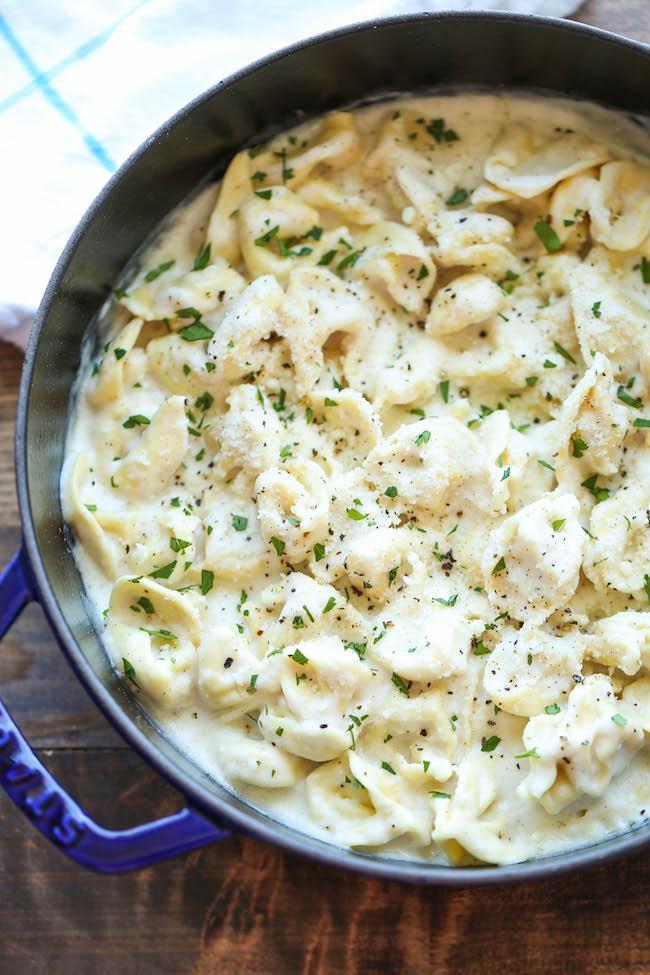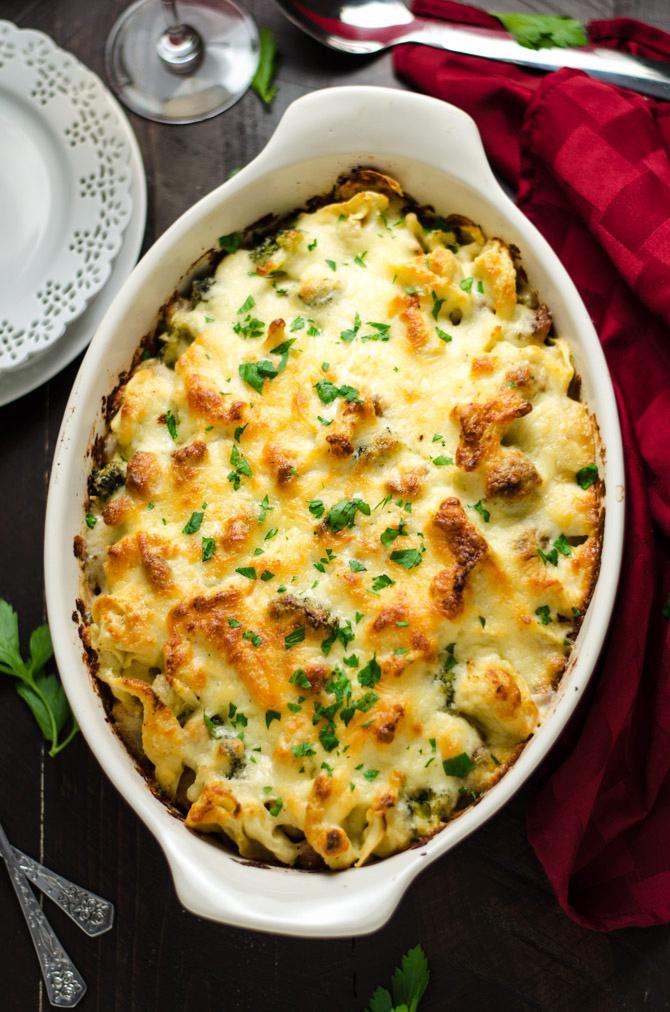The first image is the image on the left, the second image is the image on the right. For the images shown, is this caption "The right image contains a fork." true? Answer yes or no. No. The first image is the image on the left, the second image is the image on the right. For the images shown, is this caption "All broccoli dishes are served on white plates." true? Answer yes or no. No. 